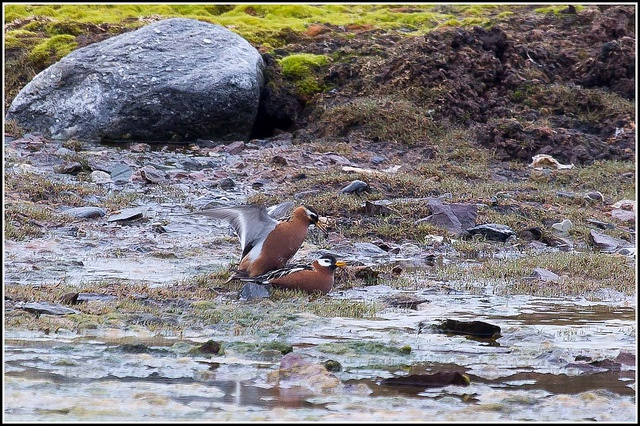Describe the objects in this image and their specific colors. I can see bird in black, gray, darkgray, maroon, and brown tones and bird in black, brown, and maroon tones in this image. 